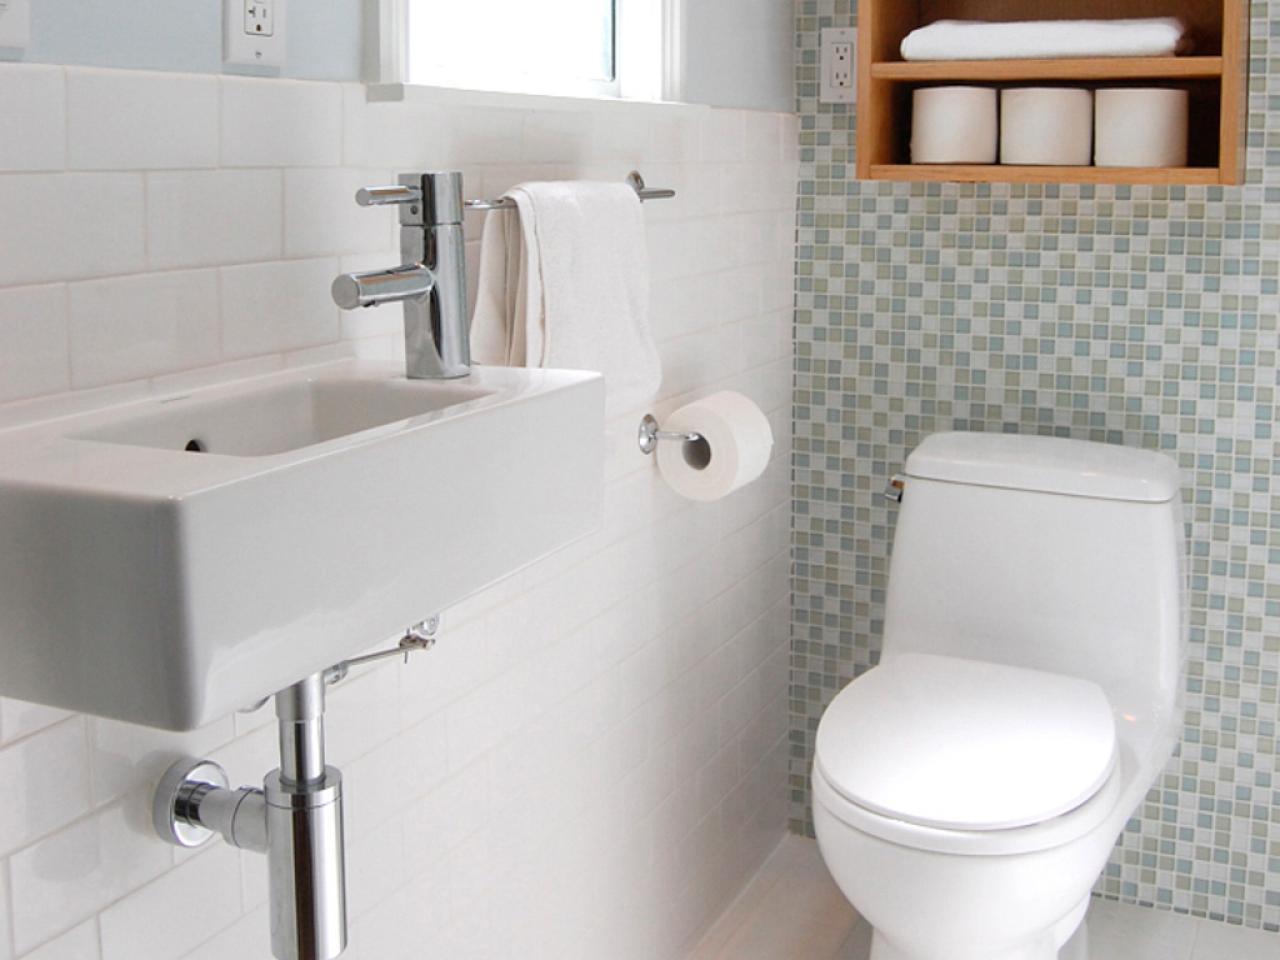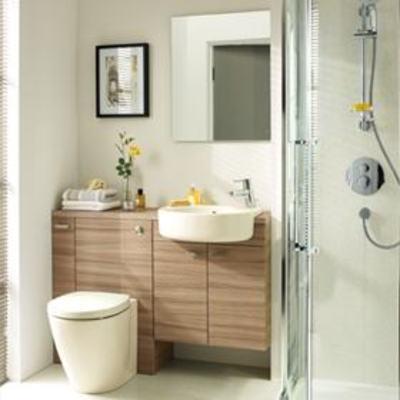The first image is the image on the left, the second image is the image on the right. Examine the images to the left and right. Is the description "A white commode is attached at one end of a white vanity, with a white sink attached at the other end over double doors." accurate? Answer yes or no. No. The first image is the image on the left, the second image is the image on the right. Examine the images to the left and right. Is the description "One of the toilets is connected to a wood cabinet." accurate? Answer yes or no. Yes. 